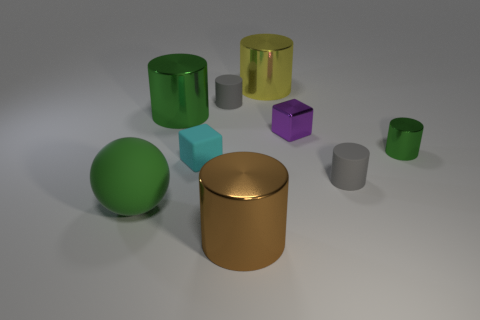Is the number of brown metal cylinders greater than the number of tiny rubber cylinders?
Your response must be concise. No. What number of other objects are the same material as the brown thing?
Your answer should be very brief. 4. What shape is the tiny gray thing that is to the right of the gray matte cylinder that is behind the green metallic cylinder that is to the right of the large brown metal cylinder?
Offer a very short reply. Cylinder. Are there fewer big metal objects in front of the large green rubber object than green rubber objects to the left of the metallic cube?
Ensure brevity in your answer.  No. Are there any metallic objects of the same color as the large matte object?
Offer a terse response. Yes. Are the big green sphere and the large green thing to the right of the green matte thing made of the same material?
Your answer should be very brief. No. Is there a tiny gray matte cylinder on the left side of the small thing in front of the cyan object?
Give a very brief answer. Yes. The large metallic object that is behind the large sphere and in front of the yellow metallic object is what color?
Offer a terse response. Green. What is the size of the matte cube?
Your response must be concise. Small. How many objects are the same size as the brown cylinder?
Keep it short and to the point. 3. 